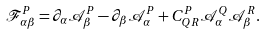Convert formula to latex. <formula><loc_0><loc_0><loc_500><loc_500>\mathcal { F } _ { \alpha \beta } ^ { P } = \partial _ { \alpha } \mathcal { A } ^ { P } _ { \beta } - \partial _ { \beta } \mathcal { A } ^ { P } _ { \alpha } + C _ { Q R } ^ { P } \mathcal { A } ^ { Q } _ { \alpha } \mathcal { A } ^ { R } _ { \beta } .</formula> 